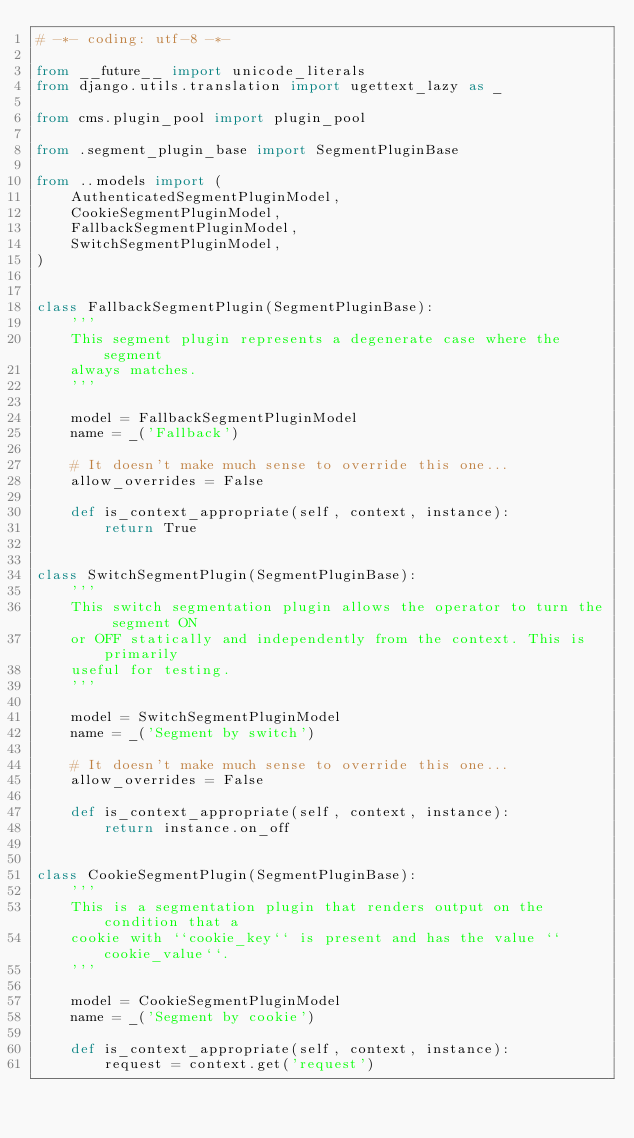<code> <loc_0><loc_0><loc_500><loc_500><_Python_># -*- coding: utf-8 -*-

from __future__ import unicode_literals
from django.utils.translation import ugettext_lazy as _

from cms.plugin_pool import plugin_pool

from .segment_plugin_base import SegmentPluginBase

from ..models import (
    AuthenticatedSegmentPluginModel,
    CookieSegmentPluginModel,
    FallbackSegmentPluginModel,
    SwitchSegmentPluginModel,
)


class FallbackSegmentPlugin(SegmentPluginBase):
    '''
    This segment plugin represents a degenerate case where the segment
    always matches.
    '''

    model = FallbackSegmentPluginModel
    name = _('Fallback')

    # It doesn't make much sense to override this one...
    allow_overrides = False

    def is_context_appropriate(self, context, instance):
        return True


class SwitchSegmentPlugin(SegmentPluginBase):
    '''
    This switch segmentation plugin allows the operator to turn the segment ON
    or OFF statically and independently from the context. This is primarily
    useful for testing.
    '''

    model = SwitchSegmentPluginModel
    name = _('Segment by switch')

    # It doesn't make much sense to override this one...
    allow_overrides = False

    def is_context_appropriate(self, context, instance):
        return instance.on_off


class CookieSegmentPlugin(SegmentPluginBase):
    '''
    This is a segmentation plugin that renders output on the condition that a
    cookie with ``cookie_key`` is present and has the value ``cookie_value``.
    '''

    model = CookieSegmentPluginModel
    name = _('Segment by cookie')

    def is_context_appropriate(self, context, instance):
        request = context.get('request')</code> 